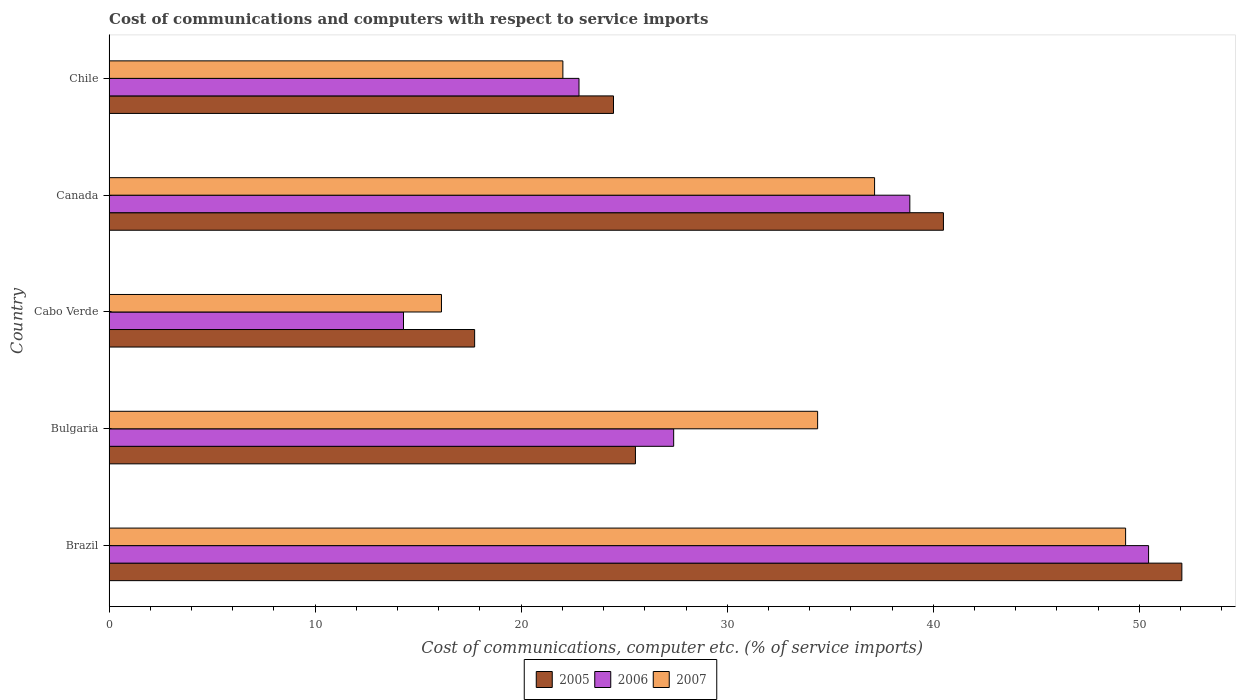How many groups of bars are there?
Ensure brevity in your answer.  5. Are the number of bars per tick equal to the number of legend labels?
Give a very brief answer. Yes. Are the number of bars on each tick of the Y-axis equal?
Keep it short and to the point. Yes. In how many cases, is the number of bars for a given country not equal to the number of legend labels?
Keep it short and to the point. 0. What is the cost of communications and computers in 2007 in Bulgaria?
Your response must be concise. 34.39. Across all countries, what is the maximum cost of communications and computers in 2005?
Your response must be concise. 52.06. Across all countries, what is the minimum cost of communications and computers in 2007?
Ensure brevity in your answer.  16.13. In which country was the cost of communications and computers in 2005 minimum?
Offer a terse response. Cabo Verde. What is the total cost of communications and computers in 2006 in the graph?
Offer a very short reply. 153.81. What is the difference between the cost of communications and computers in 2005 in Brazil and that in Canada?
Make the answer very short. 11.57. What is the difference between the cost of communications and computers in 2007 in Canada and the cost of communications and computers in 2005 in Chile?
Give a very brief answer. 12.67. What is the average cost of communications and computers in 2006 per country?
Your answer should be compact. 30.76. What is the difference between the cost of communications and computers in 2005 and cost of communications and computers in 2006 in Cabo Verde?
Provide a short and direct response. 3.45. In how many countries, is the cost of communications and computers in 2005 greater than 22 %?
Offer a terse response. 4. What is the ratio of the cost of communications and computers in 2006 in Bulgaria to that in Chile?
Offer a terse response. 1.2. What is the difference between the highest and the second highest cost of communications and computers in 2006?
Keep it short and to the point. 11.59. What is the difference between the highest and the lowest cost of communications and computers in 2007?
Give a very brief answer. 33.2. Is the sum of the cost of communications and computers in 2007 in Brazil and Cabo Verde greater than the maximum cost of communications and computers in 2006 across all countries?
Offer a terse response. Yes. What does the 3rd bar from the bottom in Canada represents?
Provide a succinct answer. 2007. Is it the case that in every country, the sum of the cost of communications and computers in 2005 and cost of communications and computers in 2007 is greater than the cost of communications and computers in 2006?
Offer a terse response. Yes. Are all the bars in the graph horizontal?
Give a very brief answer. Yes. Are the values on the major ticks of X-axis written in scientific E-notation?
Your answer should be compact. No. Does the graph contain grids?
Give a very brief answer. No. Where does the legend appear in the graph?
Provide a short and direct response. Bottom center. How many legend labels are there?
Keep it short and to the point. 3. How are the legend labels stacked?
Give a very brief answer. Horizontal. What is the title of the graph?
Provide a short and direct response. Cost of communications and computers with respect to service imports. What is the label or title of the X-axis?
Provide a short and direct response. Cost of communications, computer etc. (% of service imports). What is the Cost of communications, computer etc. (% of service imports) of 2005 in Brazil?
Keep it short and to the point. 52.06. What is the Cost of communications, computer etc. (% of service imports) of 2006 in Brazil?
Provide a short and direct response. 50.45. What is the Cost of communications, computer etc. (% of service imports) in 2007 in Brazil?
Offer a terse response. 49.34. What is the Cost of communications, computer etc. (% of service imports) of 2005 in Bulgaria?
Make the answer very short. 25.55. What is the Cost of communications, computer etc. (% of service imports) in 2006 in Bulgaria?
Offer a terse response. 27.4. What is the Cost of communications, computer etc. (% of service imports) of 2007 in Bulgaria?
Your response must be concise. 34.39. What is the Cost of communications, computer etc. (% of service imports) in 2005 in Cabo Verde?
Offer a very short reply. 17.74. What is the Cost of communications, computer etc. (% of service imports) in 2006 in Cabo Verde?
Offer a terse response. 14.29. What is the Cost of communications, computer etc. (% of service imports) of 2007 in Cabo Verde?
Give a very brief answer. 16.13. What is the Cost of communications, computer etc. (% of service imports) of 2005 in Canada?
Make the answer very short. 40.49. What is the Cost of communications, computer etc. (% of service imports) of 2006 in Canada?
Keep it short and to the point. 38.86. What is the Cost of communications, computer etc. (% of service imports) in 2007 in Canada?
Your answer should be compact. 37.15. What is the Cost of communications, computer etc. (% of service imports) in 2005 in Chile?
Provide a succinct answer. 24.48. What is the Cost of communications, computer etc. (% of service imports) in 2006 in Chile?
Provide a short and direct response. 22.81. What is the Cost of communications, computer etc. (% of service imports) in 2007 in Chile?
Keep it short and to the point. 22.02. Across all countries, what is the maximum Cost of communications, computer etc. (% of service imports) in 2005?
Ensure brevity in your answer.  52.06. Across all countries, what is the maximum Cost of communications, computer etc. (% of service imports) in 2006?
Provide a short and direct response. 50.45. Across all countries, what is the maximum Cost of communications, computer etc. (% of service imports) in 2007?
Give a very brief answer. 49.34. Across all countries, what is the minimum Cost of communications, computer etc. (% of service imports) in 2005?
Provide a short and direct response. 17.74. Across all countries, what is the minimum Cost of communications, computer etc. (% of service imports) in 2006?
Your answer should be compact. 14.29. Across all countries, what is the minimum Cost of communications, computer etc. (% of service imports) of 2007?
Ensure brevity in your answer.  16.13. What is the total Cost of communications, computer etc. (% of service imports) of 2005 in the graph?
Your answer should be very brief. 160.33. What is the total Cost of communications, computer etc. (% of service imports) in 2006 in the graph?
Keep it short and to the point. 153.81. What is the total Cost of communications, computer etc. (% of service imports) in 2007 in the graph?
Keep it short and to the point. 159.03. What is the difference between the Cost of communications, computer etc. (% of service imports) of 2005 in Brazil and that in Bulgaria?
Give a very brief answer. 26.52. What is the difference between the Cost of communications, computer etc. (% of service imports) in 2006 in Brazil and that in Bulgaria?
Offer a terse response. 23.05. What is the difference between the Cost of communications, computer etc. (% of service imports) in 2007 in Brazil and that in Bulgaria?
Ensure brevity in your answer.  14.95. What is the difference between the Cost of communications, computer etc. (% of service imports) of 2005 in Brazil and that in Cabo Verde?
Ensure brevity in your answer.  34.32. What is the difference between the Cost of communications, computer etc. (% of service imports) of 2006 in Brazil and that in Cabo Verde?
Give a very brief answer. 36.16. What is the difference between the Cost of communications, computer etc. (% of service imports) in 2007 in Brazil and that in Cabo Verde?
Your answer should be compact. 33.2. What is the difference between the Cost of communications, computer etc. (% of service imports) in 2005 in Brazil and that in Canada?
Provide a short and direct response. 11.57. What is the difference between the Cost of communications, computer etc. (% of service imports) in 2006 in Brazil and that in Canada?
Keep it short and to the point. 11.59. What is the difference between the Cost of communications, computer etc. (% of service imports) of 2007 in Brazil and that in Canada?
Make the answer very short. 12.18. What is the difference between the Cost of communications, computer etc. (% of service imports) of 2005 in Brazil and that in Chile?
Keep it short and to the point. 27.58. What is the difference between the Cost of communications, computer etc. (% of service imports) of 2006 in Brazil and that in Chile?
Make the answer very short. 27.64. What is the difference between the Cost of communications, computer etc. (% of service imports) of 2007 in Brazil and that in Chile?
Keep it short and to the point. 27.31. What is the difference between the Cost of communications, computer etc. (% of service imports) in 2005 in Bulgaria and that in Cabo Verde?
Your response must be concise. 7.8. What is the difference between the Cost of communications, computer etc. (% of service imports) in 2006 in Bulgaria and that in Cabo Verde?
Your answer should be very brief. 13.11. What is the difference between the Cost of communications, computer etc. (% of service imports) in 2007 in Bulgaria and that in Cabo Verde?
Give a very brief answer. 18.26. What is the difference between the Cost of communications, computer etc. (% of service imports) in 2005 in Bulgaria and that in Canada?
Provide a short and direct response. -14.95. What is the difference between the Cost of communications, computer etc. (% of service imports) of 2006 in Bulgaria and that in Canada?
Make the answer very short. -11.46. What is the difference between the Cost of communications, computer etc. (% of service imports) of 2007 in Bulgaria and that in Canada?
Ensure brevity in your answer.  -2.76. What is the difference between the Cost of communications, computer etc. (% of service imports) of 2005 in Bulgaria and that in Chile?
Your response must be concise. 1.06. What is the difference between the Cost of communications, computer etc. (% of service imports) in 2006 in Bulgaria and that in Chile?
Offer a very short reply. 4.59. What is the difference between the Cost of communications, computer etc. (% of service imports) of 2007 in Bulgaria and that in Chile?
Make the answer very short. 12.36. What is the difference between the Cost of communications, computer etc. (% of service imports) in 2005 in Cabo Verde and that in Canada?
Your answer should be very brief. -22.75. What is the difference between the Cost of communications, computer etc. (% of service imports) in 2006 in Cabo Verde and that in Canada?
Keep it short and to the point. -24.57. What is the difference between the Cost of communications, computer etc. (% of service imports) of 2007 in Cabo Verde and that in Canada?
Your response must be concise. -21.02. What is the difference between the Cost of communications, computer etc. (% of service imports) of 2005 in Cabo Verde and that in Chile?
Your answer should be very brief. -6.74. What is the difference between the Cost of communications, computer etc. (% of service imports) of 2006 in Cabo Verde and that in Chile?
Keep it short and to the point. -8.52. What is the difference between the Cost of communications, computer etc. (% of service imports) in 2007 in Cabo Verde and that in Chile?
Provide a succinct answer. -5.89. What is the difference between the Cost of communications, computer etc. (% of service imports) in 2005 in Canada and that in Chile?
Your answer should be compact. 16.01. What is the difference between the Cost of communications, computer etc. (% of service imports) in 2006 in Canada and that in Chile?
Give a very brief answer. 16.06. What is the difference between the Cost of communications, computer etc. (% of service imports) in 2007 in Canada and that in Chile?
Ensure brevity in your answer.  15.13. What is the difference between the Cost of communications, computer etc. (% of service imports) of 2005 in Brazil and the Cost of communications, computer etc. (% of service imports) of 2006 in Bulgaria?
Keep it short and to the point. 24.66. What is the difference between the Cost of communications, computer etc. (% of service imports) of 2005 in Brazil and the Cost of communications, computer etc. (% of service imports) of 2007 in Bulgaria?
Your response must be concise. 17.68. What is the difference between the Cost of communications, computer etc. (% of service imports) of 2006 in Brazil and the Cost of communications, computer etc. (% of service imports) of 2007 in Bulgaria?
Keep it short and to the point. 16.06. What is the difference between the Cost of communications, computer etc. (% of service imports) of 2005 in Brazil and the Cost of communications, computer etc. (% of service imports) of 2006 in Cabo Verde?
Offer a terse response. 37.78. What is the difference between the Cost of communications, computer etc. (% of service imports) in 2005 in Brazil and the Cost of communications, computer etc. (% of service imports) in 2007 in Cabo Verde?
Your answer should be compact. 35.93. What is the difference between the Cost of communications, computer etc. (% of service imports) of 2006 in Brazil and the Cost of communications, computer etc. (% of service imports) of 2007 in Cabo Verde?
Provide a short and direct response. 34.32. What is the difference between the Cost of communications, computer etc. (% of service imports) in 2005 in Brazil and the Cost of communications, computer etc. (% of service imports) in 2006 in Canada?
Your answer should be compact. 13.2. What is the difference between the Cost of communications, computer etc. (% of service imports) of 2005 in Brazil and the Cost of communications, computer etc. (% of service imports) of 2007 in Canada?
Ensure brevity in your answer.  14.91. What is the difference between the Cost of communications, computer etc. (% of service imports) of 2006 in Brazil and the Cost of communications, computer etc. (% of service imports) of 2007 in Canada?
Keep it short and to the point. 13.3. What is the difference between the Cost of communications, computer etc. (% of service imports) of 2005 in Brazil and the Cost of communications, computer etc. (% of service imports) of 2006 in Chile?
Keep it short and to the point. 29.26. What is the difference between the Cost of communications, computer etc. (% of service imports) in 2005 in Brazil and the Cost of communications, computer etc. (% of service imports) in 2007 in Chile?
Your response must be concise. 30.04. What is the difference between the Cost of communications, computer etc. (% of service imports) in 2006 in Brazil and the Cost of communications, computer etc. (% of service imports) in 2007 in Chile?
Ensure brevity in your answer.  28.43. What is the difference between the Cost of communications, computer etc. (% of service imports) in 2005 in Bulgaria and the Cost of communications, computer etc. (% of service imports) in 2006 in Cabo Verde?
Your answer should be very brief. 11.26. What is the difference between the Cost of communications, computer etc. (% of service imports) of 2005 in Bulgaria and the Cost of communications, computer etc. (% of service imports) of 2007 in Cabo Verde?
Give a very brief answer. 9.41. What is the difference between the Cost of communications, computer etc. (% of service imports) of 2006 in Bulgaria and the Cost of communications, computer etc. (% of service imports) of 2007 in Cabo Verde?
Keep it short and to the point. 11.27. What is the difference between the Cost of communications, computer etc. (% of service imports) in 2005 in Bulgaria and the Cost of communications, computer etc. (% of service imports) in 2006 in Canada?
Your answer should be very brief. -13.32. What is the difference between the Cost of communications, computer etc. (% of service imports) in 2005 in Bulgaria and the Cost of communications, computer etc. (% of service imports) in 2007 in Canada?
Provide a succinct answer. -11.61. What is the difference between the Cost of communications, computer etc. (% of service imports) of 2006 in Bulgaria and the Cost of communications, computer etc. (% of service imports) of 2007 in Canada?
Your response must be concise. -9.75. What is the difference between the Cost of communications, computer etc. (% of service imports) in 2005 in Bulgaria and the Cost of communications, computer etc. (% of service imports) in 2006 in Chile?
Your response must be concise. 2.74. What is the difference between the Cost of communications, computer etc. (% of service imports) in 2005 in Bulgaria and the Cost of communications, computer etc. (% of service imports) in 2007 in Chile?
Your answer should be compact. 3.52. What is the difference between the Cost of communications, computer etc. (% of service imports) in 2006 in Bulgaria and the Cost of communications, computer etc. (% of service imports) in 2007 in Chile?
Make the answer very short. 5.38. What is the difference between the Cost of communications, computer etc. (% of service imports) in 2005 in Cabo Verde and the Cost of communications, computer etc. (% of service imports) in 2006 in Canada?
Offer a terse response. -21.12. What is the difference between the Cost of communications, computer etc. (% of service imports) of 2005 in Cabo Verde and the Cost of communications, computer etc. (% of service imports) of 2007 in Canada?
Offer a very short reply. -19.41. What is the difference between the Cost of communications, computer etc. (% of service imports) in 2006 in Cabo Verde and the Cost of communications, computer etc. (% of service imports) in 2007 in Canada?
Offer a very short reply. -22.86. What is the difference between the Cost of communications, computer etc. (% of service imports) in 2005 in Cabo Verde and the Cost of communications, computer etc. (% of service imports) in 2006 in Chile?
Offer a terse response. -5.07. What is the difference between the Cost of communications, computer etc. (% of service imports) of 2005 in Cabo Verde and the Cost of communications, computer etc. (% of service imports) of 2007 in Chile?
Provide a succinct answer. -4.28. What is the difference between the Cost of communications, computer etc. (% of service imports) of 2006 in Cabo Verde and the Cost of communications, computer etc. (% of service imports) of 2007 in Chile?
Your answer should be very brief. -7.73. What is the difference between the Cost of communications, computer etc. (% of service imports) of 2005 in Canada and the Cost of communications, computer etc. (% of service imports) of 2006 in Chile?
Make the answer very short. 17.69. What is the difference between the Cost of communications, computer etc. (% of service imports) of 2005 in Canada and the Cost of communications, computer etc. (% of service imports) of 2007 in Chile?
Offer a terse response. 18.47. What is the difference between the Cost of communications, computer etc. (% of service imports) in 2006 in Canada and the Cost of communications, computer etc. (% of service imports) in 2007 in Chile?
Keep it short and to the point. 16.84. What is the average Cost of communications, computer etc. (% of service imports) of 2005 per country?
Offer a terse response. 32.07. What is the average Cost of communications, computer etc. (% of service imports) of 2006 per country?
Make the answer very short. 30.76. What is the average Cost of communications, computer etc. (% of service imports) in 2007 per country?
Give a very brief answer. 31.81. What is the difference between the Cost of communications, computer etc. (% of service imports) of 2005 and Cost of communications, computer etc. (% of service imports) of 2006 in Brazil?
Your answer should be very brief. 1.61. What is the difference between the Cost of communications, computer etc. (% of service imports) in 2005 and Cost of communications, computer etc. (% of service imports) in 2007 in Brazil?
Your response must be concise. 2.73. What is the difference between the Cost of communications, computer etc. (% of service imports) of 2006 and Cost of communications, computer etc. (% of service imports) of 2007 in Brazil?
Make the answer very short. 1.11. What is the difference between the Cost of communications, computer etc. (% of service imports) of 2005 and Cost of communications, computer etc. (% of service imports) of 2006 in Bulgaria?
Offer a terse response. -1.86. What is the difference between the Cost of communications, computer etc. (% of service imports) in 2005 and Cost of communications, computer etc. (% of service imports) in 2007 in Bulgaria?
Offer a very short reply. -8.84. What is the difference between the Cost of communications, computer etc. (% of service imports) of 2006 and Cost of communications, computer etc. (% of service imports) of 2007 in Bulgaria?
Offer a very short reply. -6.99. What is the difference between the Cost of communications, computer etc. (% of service imports) of 2005 and Cost of communications, computer etc. (% of service imports) of 2006 in Cabo Verde?
Your response must be concise. 3.45. What is the difference between the Cost of communications, computer etc. (% of service imports) of 2005 and Cost of communications, computer etc. (% of service imports) of 2007 in Cabo Verde?
Your answer should be very brief. 1.61. What is the difference between the Cost of communications, computer etc. (% of service imports) of 2006 and Cost of communications, computer etc. (% of service imports) of 2007 in Cabo Verde?
Give a very brief answer. -1.84. What is the difference between the Cost of communications, computer etc. (% of service imports) in 2005 and Cost of communications, computer etc. (% of service imports) in 2006 in Canada?
Make the answer very short. 1.63. What is the difference between the Cost of communications, computer etc. (% of service imports) of 2005 and Cost of communications, computer etc. (% of service imports) of 2007 in Canada?
Your response must be concise. 3.34. What is the difference between the Cost of communications, computer etc. (% of service imports) in 2006 and Cost of communications, computer etc. (% of service imports) in 2007 in Canada?
Make the answer very short. 1.71. What is the difference between the Cost of communications, computer etc. (% of service imports) of 2005 and Cost of communications, computer etc. (% of service imports) of 2006 in Chile?
Give a very brief answer. 1.67. What is the difference between the Cost of communications, computer etc. (% of service imports) of 2005 and Cost of communications, computer etc. (% of service imports) of 2007 in Chile?
Give a very brief answer. 2.46. What is the difference between the Cost of communications, computer etc. (% of service imports) in 2006 and Cost of communications, computer etc. (% of service imports) in 2007 in Chile?
Your answer should be very brief. 0.78. What is the ratio of the Cost of communications, computer etc. (% of service imports) of 2005 in Brazil to that in Bulgaria?
Your response must be concise. 2.04. What is the ratio of the Cost of communications, computer etc. (% of service imports) in 2006 in Brazil to that in Bulgaria?
Keep it short and to the point. 1.84. What is the ratio of the Cost of communications, computer etc. (% of service imports) in 2007 in Brazil to that in Bulgaria?
Your answer should be compact. 1.43. What is the ratio of the Cost of communications, computer etc. (% of service imports) of 2005 in Brazil to that in Cabo Verde?
Offer a terse response. 2.93. What is the ratio of the Cost of communications, computer etc. (% of service imports) of 2006 in Brazil to that in Cabo Verde?
Offer a terse response. 3.53. What is the ratio of the Cost of communications, computer etc. (% of service imports) in 2007 in Brazil to that in Cabo Verde?
Your answer should be very brief. 3.06. What is the ratio of the Cost of communications, computer etc. (% of service imports) in 2006 in Brazil to that in Canada?
Your response must be concise. 1.3. What is the ratio of the Cost of communications, computer etc. (% of service imports) in 2007 in Brazil to that in Canada?
Give a very brief answer. 1.33. What is the ratio of the Cost of communications, computer etc. (% of service imports) of 2005 in Brazil to that in Chile?
Your answer should be very brief. 2.13. What is the ratio of the Cost of communications, computer etc. (% of service imports) of 2006 in Brazil to that in Chile?
Provide a short and direct response. 2.21. What is the ratio of the Cost of communications, computer etc. (% of service imports) in 2007 in Brazil to that in Chile?
Your response must be concise. 2.24. What is the ratio of the Cost of communications, computer etc. (% of service imports) of 2005 in Bulgaria to that in Cabo Verde?
Provide a short and direct response. 1.44. What is the ratio of the Cost of communications, computer etc. (% of service imports) of 2006 in Bulgaria to that in Cabo Verde?
Keep it short and to the point. 1.92. What is the ratio of the Cost of communications, computer etc. (% of service imports) of 2007 in Bulgaria to that in Cabo Verde?
Give a very brief answer. 2.13. What is the ratio of the Cost of communications, computer etc. (% of service imports) in 2005 in Bulgaria to that in Canada?
Your answer should be compact. 0.63. What is the ratio of the Cost of communications, computer etc. (% of service imports) of 2006 in Bulgaria to that in Canada?
Give a very brief answer. 0.71. What is the ratio of the Cost of communications, computer etc. (% of service imports) in 2007 in Bulgaria to that in Canada?
Give a very brief answer. 0.93. What is the ratio of the Cost of communications, computer etc. (% of service imports) of 2005 in Bulgaria to that in Chile?
Give a very brief answer. 1.04. What is the ratio of the Cost of communications, computer etc. (% of service imports) in 2006 in Bulgaria to that in Chile?
Offer a very short reply. 1.2. What is the ratio of the Cost of communications, computer etc. (% of service imports) of 2007 in Bulgaria to that in Chile?
Keep it short and to the point. 1.56. What is the ratio of the Cost of communications, computer etc. (% of service imports) of 2005 in Cabo Verde to that in Canada?
Keep it short and to the point. 0.44. What is the ratio of the Cost of communications, computer etc. (% of service imports) of 2006 in Cabo Verde to that in Canada?
Your answer should be compact. 0.37. What is the ratio of the Cost of communications, computer etc. (% of service imports) in 2007 in Cabo Verde to that in Canada?
Provide a succinct answer. 0.43. What is the ratio of the Cost of communications, computer etc. (% of service imports) of 2005 in Cabo Verde to that in Chile?
Provide a succinct answer. 0.72. What is the ratio of the Cost of communications, computer etc. (% of service imports) in 2006 in Cabo Verde to that in Chile?
Your response must be concise. 0.63. What is the ratio of the Cost of communications, computer etc. (% of service imports) in 2007 in Cabo Verde to that in Chile?
Offer a very short reply. 0.73. What is the ratio of the Cost of communications, computer etc. (% of service imports) of 2005 in Canada to that in Chile?
Ensure brevity in your answer.  1.65. What is the ratio of the Cost of communications, computer etc. (% of service imports) in 2006 in Canada to that in Chile?
Make the answer very short. 1.7. What is the ratio of the Cost of communications, computer etc. (% of service imports) in 2007 in Canada to that in Chile?
Give a very brief answer. 1.69. What is the difference between the highest and the second highest Cost of communications, computer etc. (% of service imports) in 2005?
Your answer should be very brief. 11.57. What is the difference between the highest and the second highest Cost of communications, computer etc. (% of service imports) in 2006?
Ensure brevity in your answer.  11.59. What is the difference between the highest and the second highest Cost of communications, computer etc. (% of service imports) in 2007?
Provide a short and direct response. 12.18. What is the difference between the highest and the lowest Cost of communications, computer etc. (% of service imports) in 2005?
Keep it short and to the point. 34.32. What is the difference between the highest and the lowest Cost of communications, computer etc. (% of service imports) of 2006?
Give a very brief answer. 36.16. What is the difference between the highest and the lowest Cost of communications, computer etc. (% of service imports) in 2007?
Ensure brevity in your answer.  33.2. 